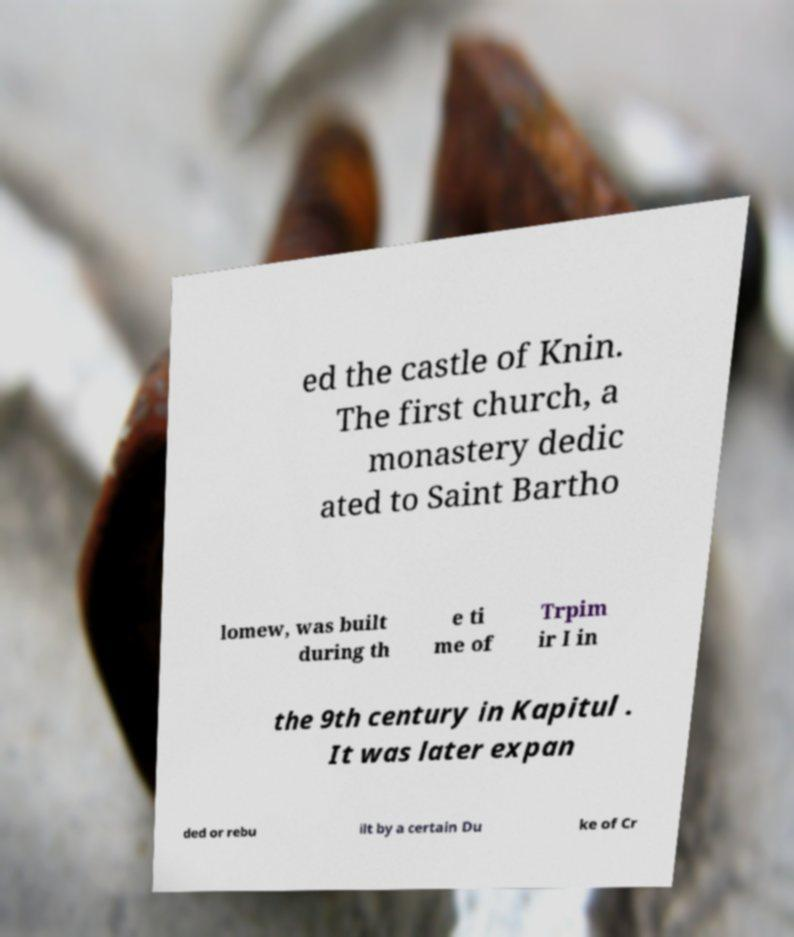Could you assist in decoding the text presented in this image and type it out clearly? ed the castle of Knin. The first church, a monastery dedic ated to Saint Bartho lomew, was built during th e ti me of Trpim ir I in the 9th century in Kapitul . It was later expan ded or rebu ilt by a certain Du ke of Cr 